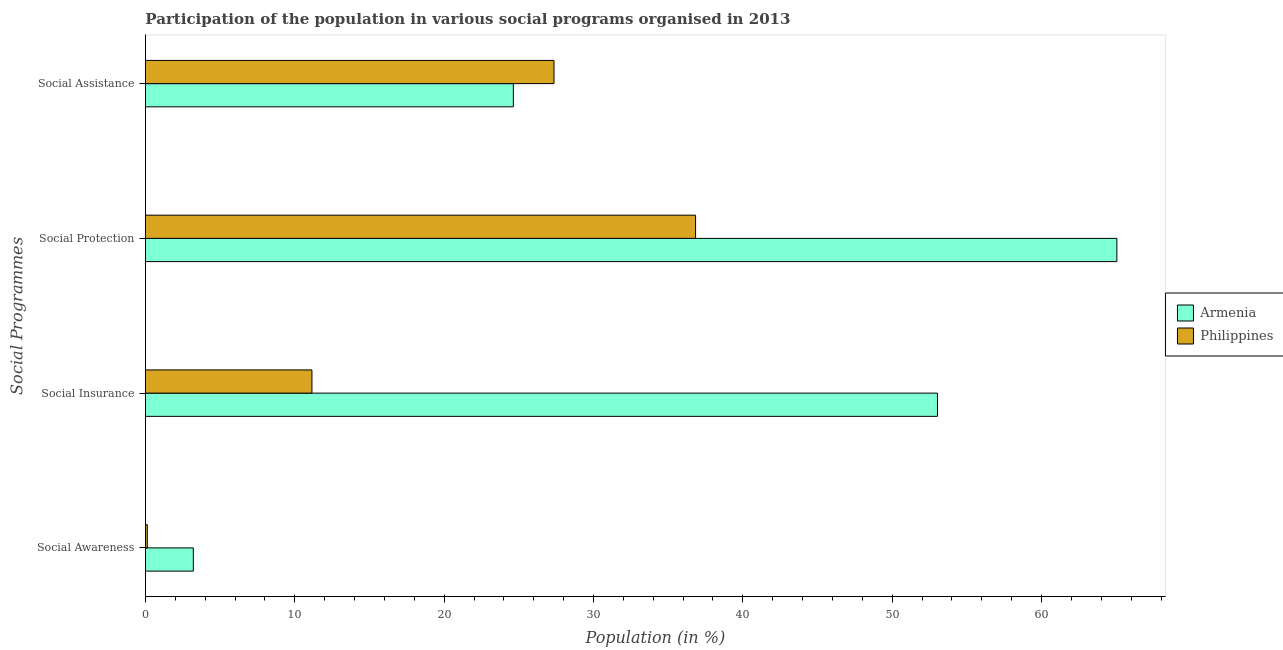How many different coloured bars are there?
Offer a terse response. 2. How many groups of bars are there?
Give a very brief answer. 4. How many bars are there on the 2nd tick from the top?
Offer a terse response. 2. How many bars are there on the 2nd tick from the bottom?
Offer a very short reply. 2. What is the label of the 4th group of bars from the top?
Your answer should be very brief. Social Awareness. What is the participation of population in social protection programs in Philippines?
Make the answer very short. 36.84. Across all countries, what is the maximum participation of population in social assistance programs?
Ensure brevity in your answer.  27.35. Across all countries, what is the minimum participation of population in social protection programs?
Provide a succinct answer. 36.84. In which country was the participation of population in social protection programs minimum?
Provide a short and direct response. Philippines. What is the total participation of population in social insurance programs in the graph?
Provide a short and direct response. 64.18. What is the difference between the participation of population in social insurance programs in Philippines and that in Armenia?
Ensure brevity in your answer.  -41.88. What is the difference between the participation of population in social awareness programs in Armenia and the participation of population in social protection programs in Philippines?
Your answer should be compact. -33.63. What is the average participation of population in social awareness programs per country?
Offer a very short reply. 1.66. What is the difference between the participation of population in social assistance programs and participation of population in social protection programs in Armenia?
Offer a terse response. -40.41. What is the ratio of the participation of population in social awareness programs in Armenia to that in Philippines?
Provide a succinct answer. 26.09. Is the participation of population in social assistance programs in Philippines less than that in Armenia?
Ensure brevity in your answer.  No. Is the difference between the participation of population in social protection programs in Philippines and Armenia greater than the difference between the participation of population in social insurance programs in Philippines and Armenia?
Make the answer very short. Yes. What is the difference between the highest and the second highest participation of population in social protection programs?
Make the answer very short. 28.21. What is the difference between the highest and the lowest participation of population in social assistance programs?
Your response must be concise. 2.72. Is the sum of the participation of population in social protection programs in Armenia and Philippines greater than the maximum participation of population in social awareness programs across all countries?
Offer a terse response. Yes. Is it the case that in every country, the sum of the participation of population in social assistance programs and participation of population in social protection programs is greater than the sum of participation of population in social insurance programs and participation of population in social awareness programs?
Make the answer very short. Yes. What does the 2nd bar from the top in Social Protection represents?
Ensure brevity in your answer.  Armenia. What does the 1st bar from the bottom in Social Protection represents?
Ensure brevity in your answer.  Armenia. How many bars are there?
Make the answer very short. 8. Are all the bars in the graph horizontal?
Ensure brevity in your answer.  Yes. What is the difference between two consecutive major ticks on the X-axis?
Provide a short and direct response. 10. How many legend labels are there?
Provide a short and direct response. 2. How are the legend labels stacked?
Provide a succinct answer. Vertical. What is the title of the graph?
Provide a short and direct response. Participation of the population in various social programs organised in 2013. Does "Europe(all income levels)" appear as one of the legend labels in the graph?
Ensure brevity in your answer.  No. What is the label or title of the Y-axis?
Your answer should be compact. Social Programmes. What is the Population (in %) in Armenia in Social Awareness?
Your response must be concise. 3.21. What is the Population (in %) of Philippines in Social Awareness?
Provide a short and direct response. 0.12. What is the Population (in %) of Armenia in Social Insurance?
Make the answer very short. 53.03. What is the Population (in %) of Philippines in Social Insurance?
Offer a very short reply. 11.15. What is the Population (in %) of Armenia in Social Protection?
Give a very brief answer. 65.04. What is the Population (in %) in Philippines in Social Protection?
Ensure brevity in your answer.  36.84. What is the Population (in %) of Armenia in Social Assistance?
Ensure brevity in your answer.  24.63. What is the Population (in %) in Philippines in Social Assistance?
Your response must be concise. 27.35. Across all Social Programmes, what is the maximum Population (in %) of Armenia?
Your answer should be compact. 65.04. Across all Social Programmes, what is the maximum Population (in %) of Philippines?
Keep it short and to the point. 36.84. Across all Social Programmes, what is the minimum Population (in %) of Armenia?
Offer a terse response. 3.21. Across all Social Programmes, what is the minimum Population (in %) of Philippines?
Your response must be concise. 0.12. What is the total Population (in %) in Armenia in the graph?
Give a very brief answer. 145.91. What is the total Population (in %) of Philippines in the graph?
Make the answer very short. 75.46. What is the difference between the Population (in %) in Armenia in Social Awareness and that in Social Insurance?
Keep it short and to the point. -49.83. What is the difference between the Population (in %) of Philippines in Social Awareness and that in Social Insurance?
Offer a terse response. -11.02. What is the difference between the Population (in %) of Armenia in Social Awareness and that in Social Protection?
Keep it short and to the point. -61.84. What is the difference between the Population (in %) in Philippines in Social Awareness and that in Social Protection?
Offer a terse response. -36.71. What is the difference between the Population (in %) in Armenia in Social Awareness and that in Social Assistance?
Offer a very short reply. -21.43. What is the difference between the Population (in %) of Philippines in Social Awareness and that in Social Assistance?
Your response must be concise. -27.23. What is the difference between the Population (in %) of Armenia in Social Insurance and that in Social Protection?
Give a very brief answer. -12.01. What is the difference between the Population (in %) of Philippines in Social Insurance and that in Social Protection?
Provide a succinct answer. -25.69. What is the difference between the Population (in %) in Armenia in Social Insurance and that in Social Assistance?
Your answer should be compact. 28.4. What is the difference between the Population (in %) in Philippines in Social Insurance and that in Social Assistance?
Offer a very short reply. -16.21. What is the difference between the Population (in %) of Armenia in Social Protection and that in Social Assistance?
Keep it short and to the point. 40.41. What is the difference between the Population (in %) of Philippines in Social Protection and that in Social Assistance?
Keep it short and to the point. 9.48. What is the difference between the Population (in %) of Armenia in Social Awareness and the Population (in %) of Philippines in Social Insurance?
Your answer should be very brief. -7.94. What is the difference between the Population (in %) of Armenia in Social Awareness and the Population (in %) of Philippines in Social Protection?
Provide a succinct answer. -33.63. What is the difference between the Population (in %) in Armenia in Social Awareness and the Population (in %) in Philippines in Social Assistance?
Provide a short and direct response. -24.15. What is the difference between the Population (in %) of Armenia in Social Insurance and the Population (in %) of Philippines in Social Protection?
Keep it short and to the point. 16.2. What is the difference between the Population (in %) of Armenia in Social Insurance and the Population (in %) of Philippines in Social Assistance?
Offer a terse response. 25.68. What is the difference between the Population (in %) of Armenia in Social Protection and the Population (in %) of Philippines in Social Assistance?
Give a very brief answer. 37.69. What is the average Population (in %) of Armenia per Social Programmes?
Ensure brevity in your answer.  36.48. What is the average Population (in %) of Philippines per Social Programmes?
Your response must be concise. 18.86. What is the difference between the Population (in %) in Armenia and Population (in %) in Philippines in Social Awareness?
Provide a succinct answer. 3.08. What is the difference between the Population (in %) in Armenia and Population (in %) in Philippines in Social Insurance?
Keep it short and to the point. 41.88. What is the difference between the Population (in %) of Armenia and Population (in %) of Philippines in Social Protection?
Ensure brevity in your answer.  28.21. What is the difference between the Population (in %) of Armenia and Population (in %) of Philippines in Social Assistance?
Give a very brief answer. -2.72. What is the ratio of the Population (in %) of Armenia in Social Awareness to that in Social Insurance?
Keep it short and to the point. 0.06. What is the ratio of the Population (in %) of Philippines in Social Awareness to that in Social Insurance?
Provide a short and direct response. 0.01. What is the ratio of the Population (in %) in Armenia in Social Awareness to that in Social Protection?
Your answer should be very brief. 0.05. What is the ratio of the Population (in %) of Philippines in Social Awareness to that in Social Protection?
Your answer should be compact. 0. What is the ratio of the Population (in %) in Armenia in Social Awareness to that in Social Assistance?
Ensure brevity in your answer.  0.13. What is the ratio of the Population (in %) of Philippines in Social Awareness to that in Social Assistance?
Make the answer very short. 0. What is the ratio of the Population (in %) in Armenia in Social Insurance to that in Social Protection?
Your answer should be compact. 0.82. What is the ratio of the Population (in %) of Philippines in Social Insurance to that in Social Protection?
Your answer should be compact. 0.3. What is the ratio of the Population (in %) of Armenia in Social Insurance to that in Social Assistance?
Provide a short and direct response. 2.15. What is the ratio of the Population (in %) in Philippines in Social Insurance to that in Social Assistance?
Your answer should be compact. 0.41. What is the ratio of the Population (in %) in Armenia in Social Protection to that in Social Assistance?
Your answer should be very brief. 2.64. What is the ratio of the Population (in %) of Philippines in Social Protection to that in Social Assistance?
Keep it short and to the point. 1.35. What is the difference between the highest and the second highest Population (in %) of Armenia?
Make the answer very short. 12.01. What is the difference between the highest and the second highest Population (in %) of Philippines?
Ensure brevity in your answer.  9.48. What is the difference between the highest and the lowest Population (in %) in Armenia?
Offer a very short reply. 61.84. What is the difference between the highest and the lowest Population (in %) in Philippines?
Provide a succinct answer. 36.71. 